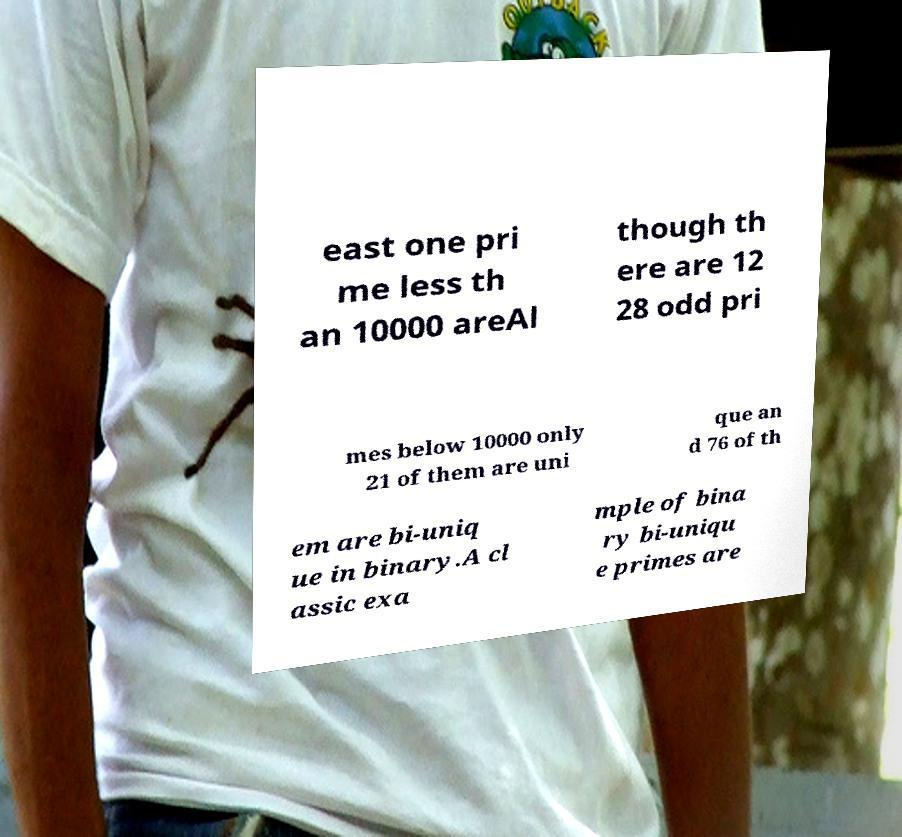Can you read and provide the text displayed in the image?This photo seems to have some interesting text. Can you extract and type it out for me? east one pri me less th an 10000 areAl though th ere are 12 28 odd pri mes below 10000 only 21 of them are uni que an d 76 of th em are bi-uniq ue in binary.A cl assic exa mple of bina ry bi-uniqu e primes are 